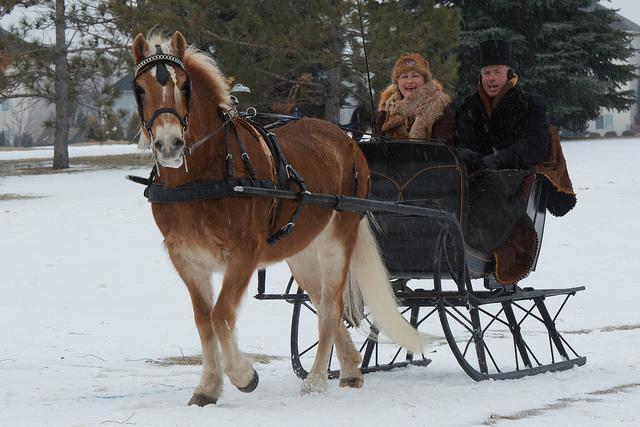How many people are in the picture?
Give a very brief answer. 2. 